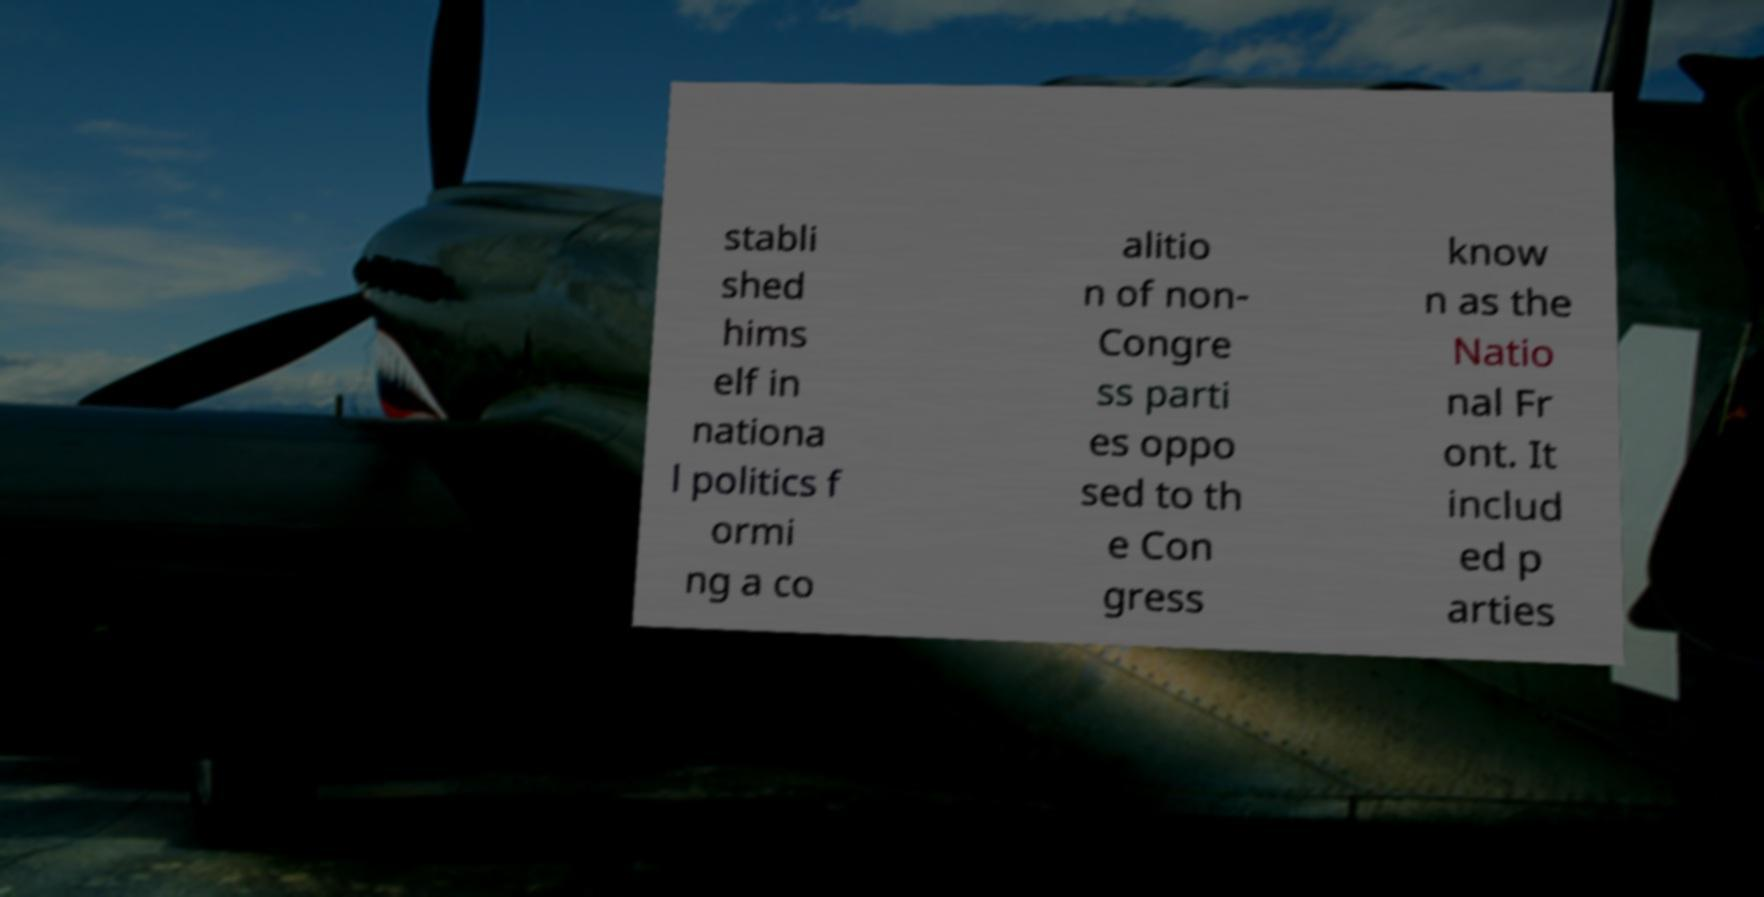Can you read and provide the text displayed in the image?This photo seems to have some interesting text. Can you extract and type it out for me? stabli shed hims elf in nationa l politics f ormi ng a co alitio n of non- Congre ss parti es oppo sed to th e Con gress know n as the Natio nal Fr ont. It includ ed p arties 